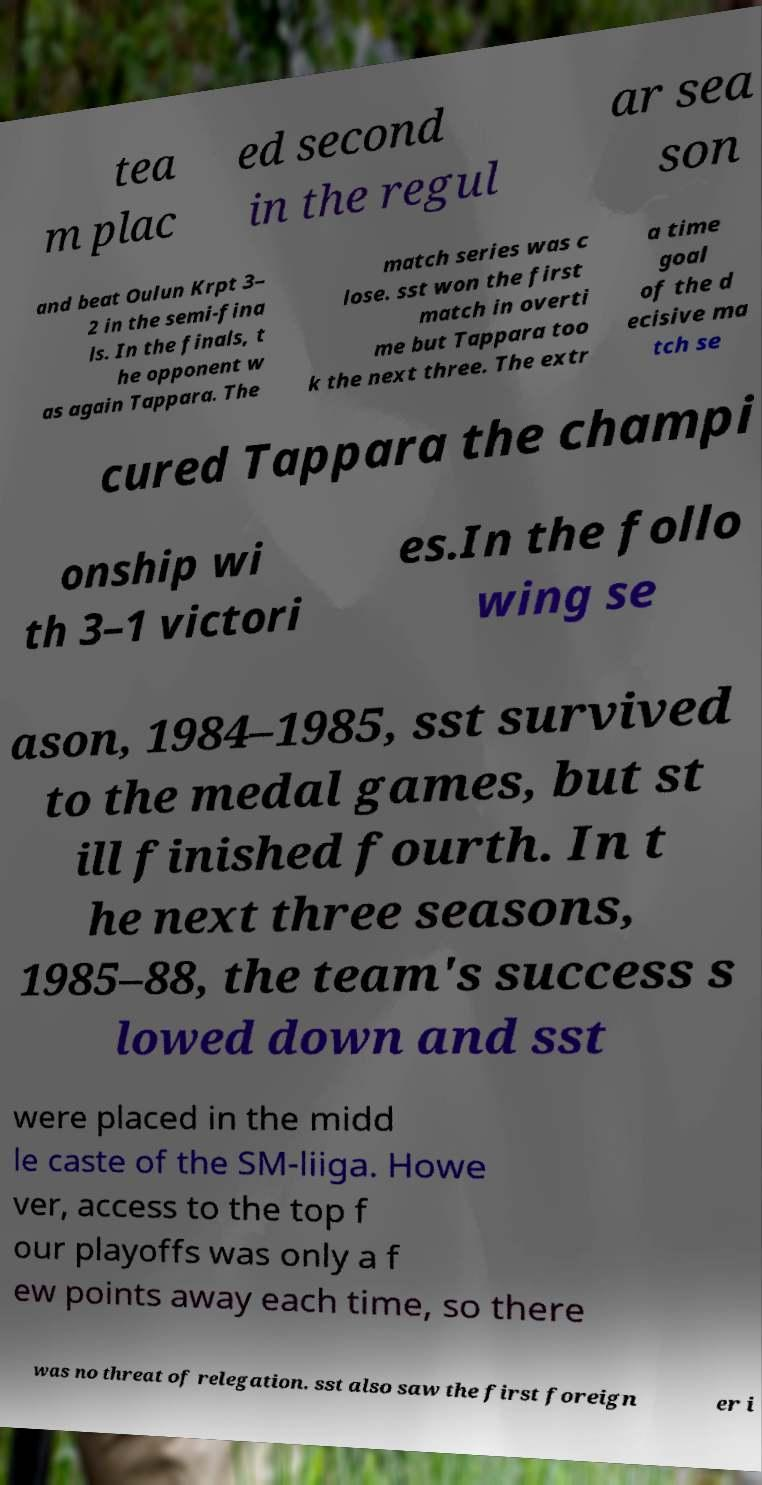Please read and relay the text visible in this image. What does it say? tea m plac ed second in the regul ar sea son and beat Oulun Krpt 3– 2 in the semi-fina ls. In the finals, t he opponent w as again Tappara. The match series was c lose. sst won the first match in overti me but Tappara too k the next three. The extr a time goal of the d ecisive ma tch se cured Tappara the champi onship wi th 3–1 victori es.In the follo wing se ason, 1984–1985, sst survived to the medal games, but st ill finished fourth. In t he next three seasons, 1985–88, the team's success s lowed down and sst were placed in the midd le caste of the SM-liiga. Howe ver, access to the top f our playoffs was only a f ew points away each time, so there was no threat of relegation. sst also saw the first foreign er i 